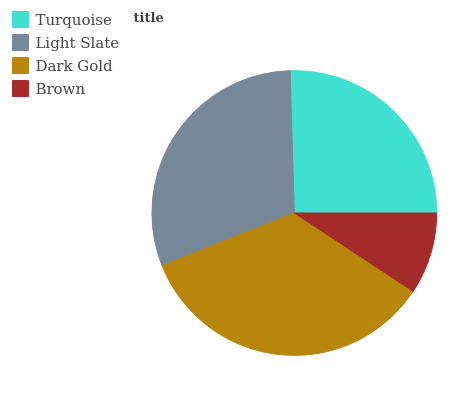Is Brown the minimum?
Answer yes or no. Yes. Is Dark Gold the maximum?
Answer yes or no. Yes. Is Light Slate the minimum?
Answer yes or no. No. Is Light Slate the maximum?
Answer yes or no. No. Is Light Slate greater than Turquoise?
Answer yes or no. Yes. Is Turquoise less than Light Slate?
Answer yes or no. Yes. Is Turquoise greater than Light Slate?
Answer yes or no. No. Is Light Slate less than Turquoise?
Answer yes or no. No. Is Light Slate the high median?
Answer yes or no. Yes. Is Turquoise the low median?
Answer yes or no. Yes. Is Turquoise the high median?
Answer yes or no. No. Is Dark Gold the low median?
Answer yes or no. No. 